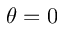Convert formula to latex. <formula><loc_0><loc_0><loc_500><loc_500>\theta = 0</formula> 